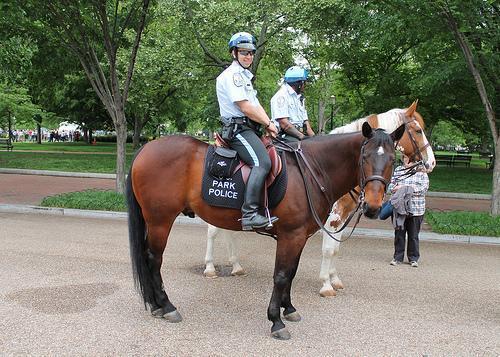How many horses in the park?
Give a very brief answer. 2. 